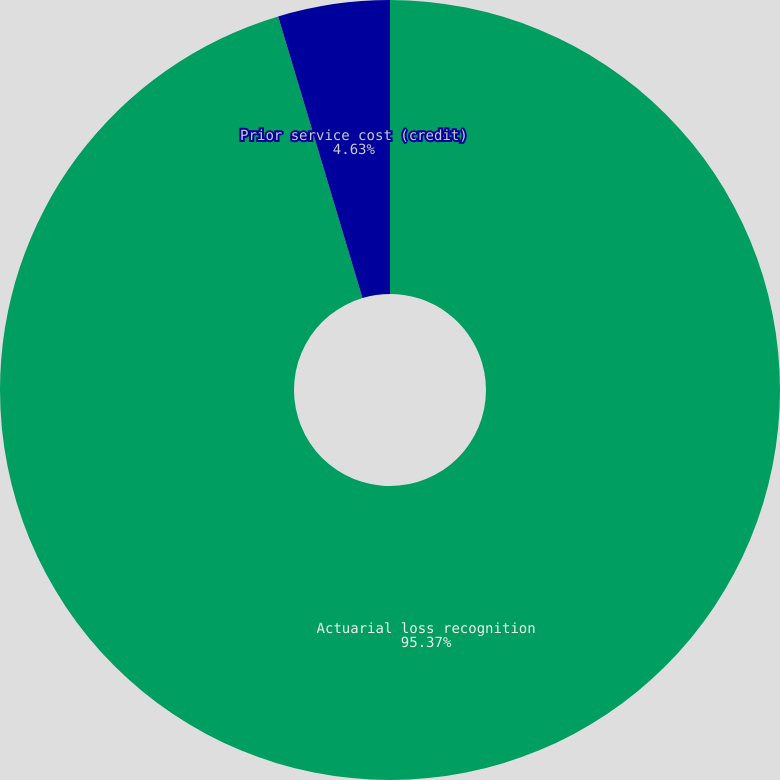Convert chart. <chart><loc_0><loc_0><loc_500><loc_500><pie_chart><fcel>Actuarial loss recognition<fcel>Prior service cost (credit)<nl><fcel>95.37%<fcel>4.63%<nl></chart> 